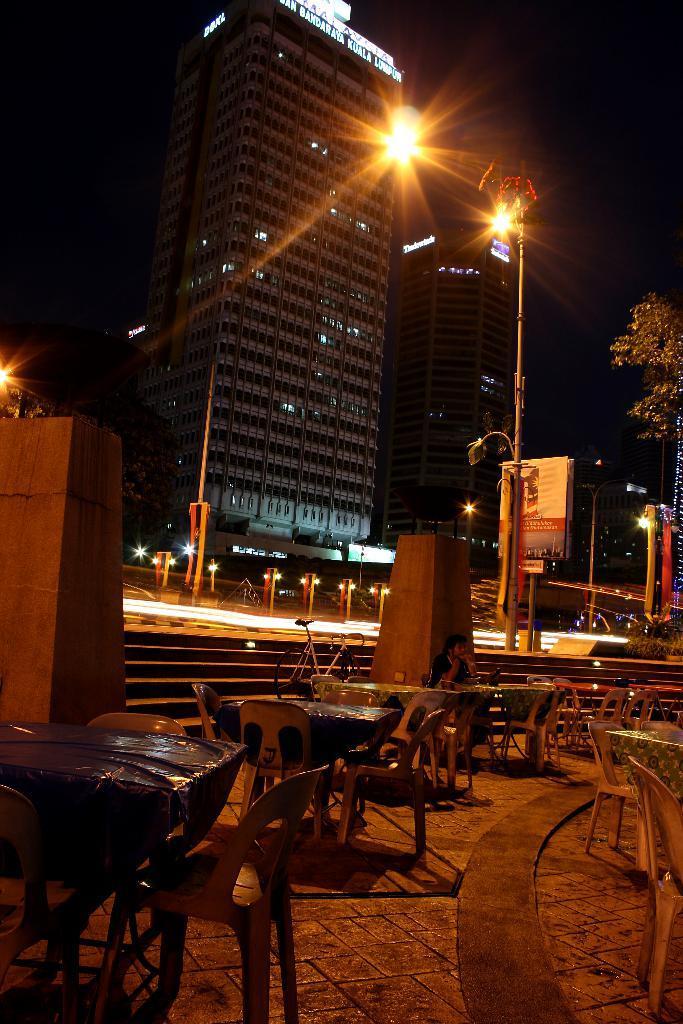How would you summarize this image in a sentence or two? This picture is clicked outside. In the center there is a staircase. In the bottom there are some tables and chairs which are empty. There is a person sitting in the center besides a pillar. There is a bicycle at the stairs. In the top of the image there is a building, besides there is another building. In the right corner there is a tree, to the left corner there is another pillar. 